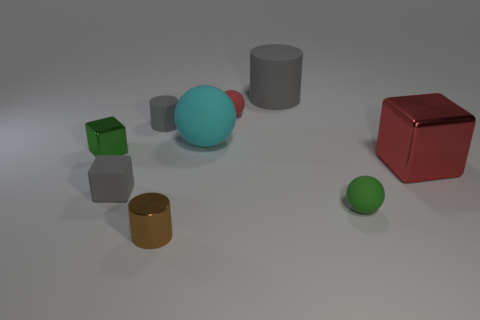The thing that is the same color as the big cube is what size?
Your answer should be very brief. Small. What shape is the red matte object that is the same size as the gray matte block?
Your response must be concise. Sphere. There is a green matte thing; are there any cylinders in front of it?
Offer a very short reply. Yes. There is a tiny brown metallic cylinder that is in front of the cyan object; are there any green metallic things that are behind it?
Your answer should be very brief. Yes. Are there fewer large balls in front of the tiny brown metal thing than tiny green rubber balls on the left side of the red metal block?
Your response must be concise. Yes. What is the shape of the small green matte thing?
Your response must be concise. Sphere. There is a cube that is behind the big red cube; what is its material?
Make the answer very short. Metal. How big is the shiny cube left of the red object in front of the red object that is behind the small metallic block?
Provide a short and direct response. Small. Do the gray object that is left of the small gray rubber cylinder and the small green object that is on the left side of the small brown metallic object have the same material?
Your response must be concise. No. How many other things are the same color as the big matte cylinder?
Make the answer very short. 2. 